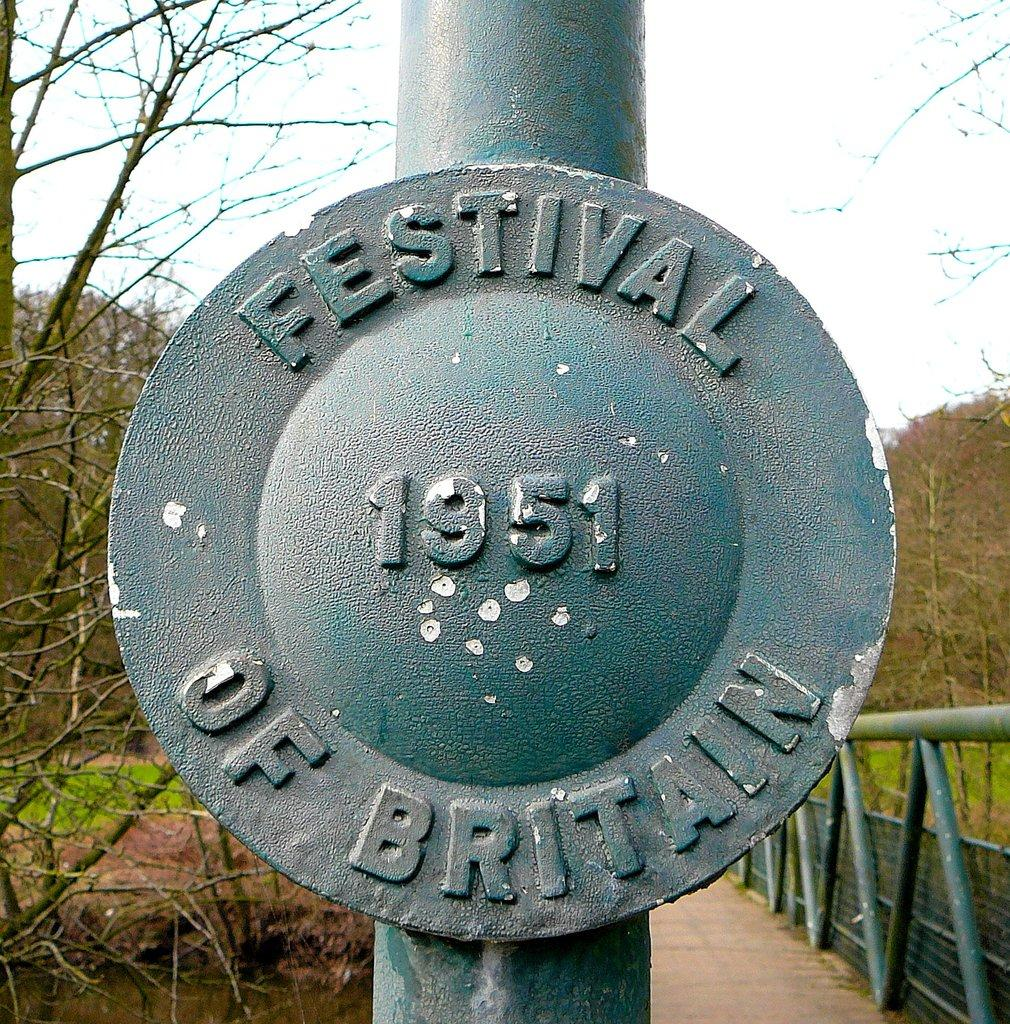What is on the pole that is visible in the image? There is text and numbers on the pole in the image. What else can be seen in the image besides the pole? There are rods visible in the image. What type of vegetation is beside the road in the image? There are trees beside the road in the image. What type of ground cover is present in the image? Grass is present in the image. What is visible in the background of the image? The sky is visible in the background of the image. How many clouds can be seen biting the rods in the image? There are no clouds visible in the image, let alone clouds biting the rods. 